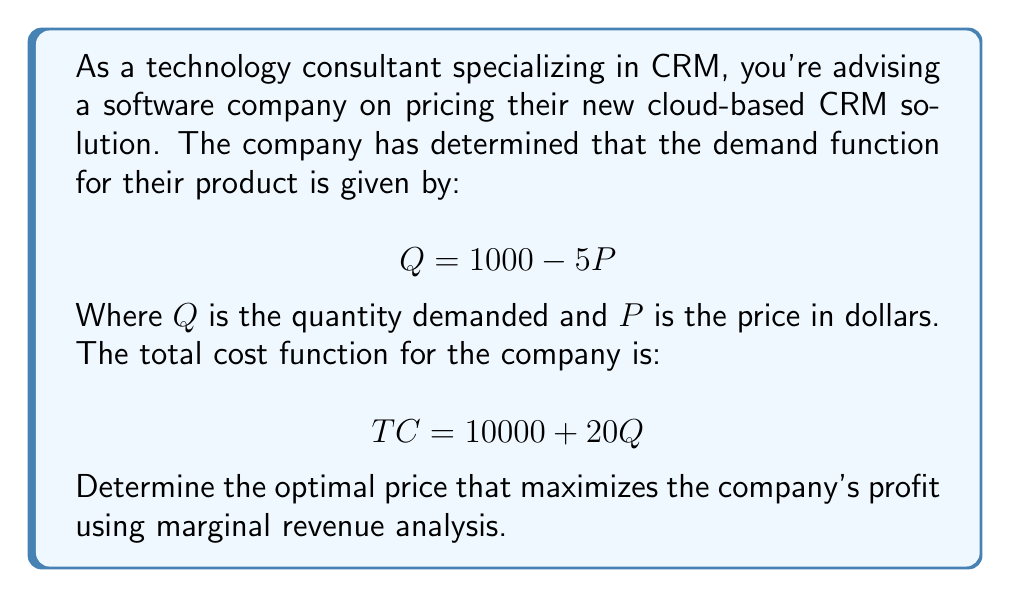Can you solve this math problem? To find the optimal price, we'll follow these steps:

1) First, we need to find the revenue function:
   $$R = P \cdot Q = P(1000 - 5P) = 1000P - 5P^2$$

2) Now, let's find the marginal revenue function by differentiating R with respect to Q:
   $$MR = \frac{dR}{dQ} = \frac{d(1000P - 5P^2)}{dQ} = 1000 - 10P$$

3) The marginal cost (MC) is the derivative of the total cost function with respect to Q:
   $$MC = \frac{dTC}{dQ} = 20$$

4) For profit maximization, we set MR = MC:
   $$1000 - 10P = 20$$
   $$980 = 10P$$
   $$P = 98$$

5) To verify this is a maximum (not minimum), we can check that the second derivative of the profit function is negative:
   $$\frac{d^2\pi}{dQ^2} = -\frac{2}{5} < 0$$

6) Now we can find Q at this optimal price:
   $$Q = 1000 - 5(98) = 510$$

7) The maximum profit can be calculated:
   $$\pi = R - TC = (98 \cdot 510) - (10000 + 20 \cdot 510) = 39980$$

Therefore, the optimal price that maximizes profit is $98.
Answer: $98 